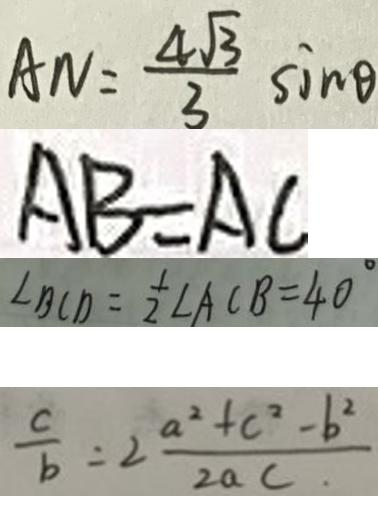Convert formula to latex. <formula><loc_0><loc_0><loc_500><loc_500>A N = \frac { 4 \sqrt { 3 } } { 3 } \sin \theta 
 A B = A C 
 \angle B C D = \frac { 1 } { 2 } \angle A C B = 4 0 ^ { \circ } 
 \frac { c } { b } = 2 \frac { a ^ { 2 } + c ^ { 2 } - b ^ { 2 } } { 2 a c }</formula> 